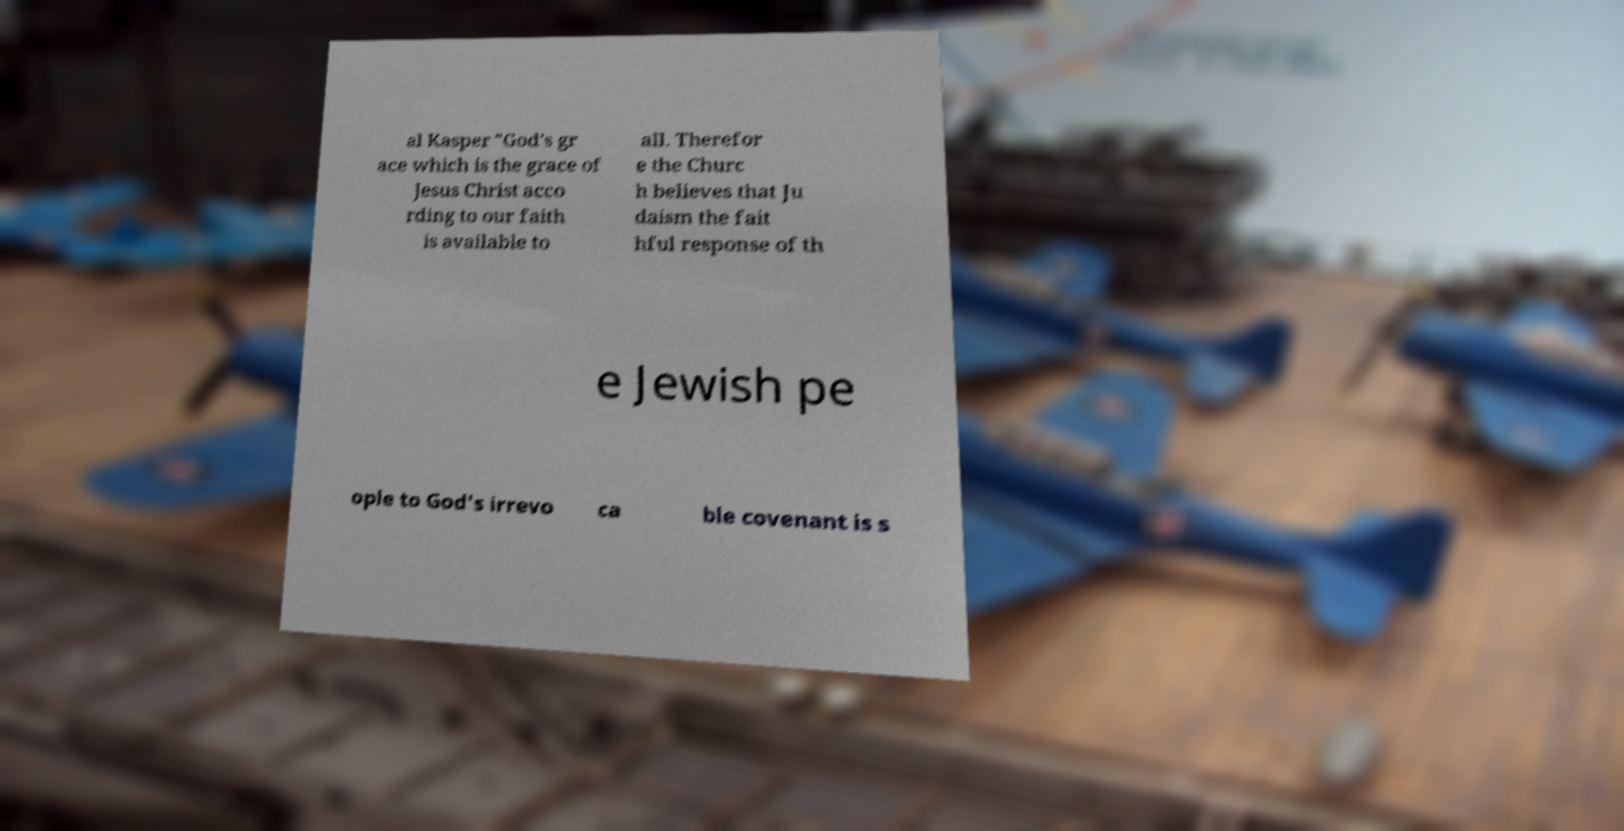There's text embedded in this image that I need extracted. Can you transcribe it verbatim? al Kasper "God's gr ace which is the grace of Jesus Christ acco rding to our faith is available to all. Therefor e the Churc h believes that Ju daism the fait hful response of th e Jewish pe ople to God's irrevo ca ble covenant is s 